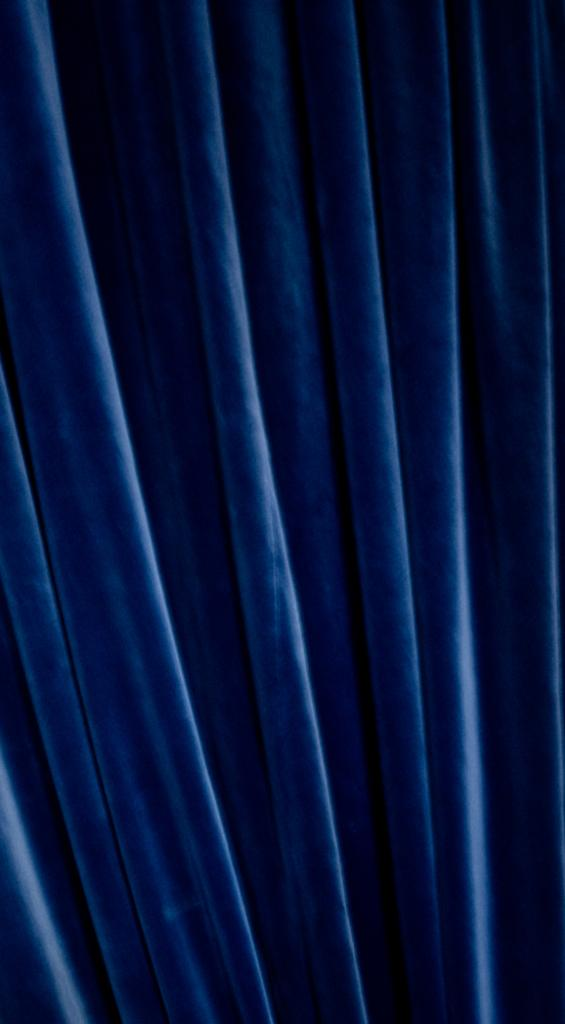What color is the curtain in the image? The curtain in the image is blue. Can you see any animals or a farm in the image? No, there are no animals or farms present in the image; it only features a blue colored curtain. What scientific discoveries are depicted in the image? There are no scientific discoveries depicted in the image; it only features a blue colored curtain. 